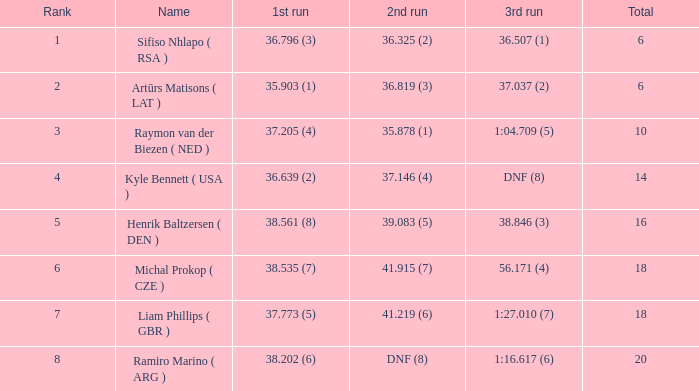Which 3rd run has rank of 1? 36.507 (1). 